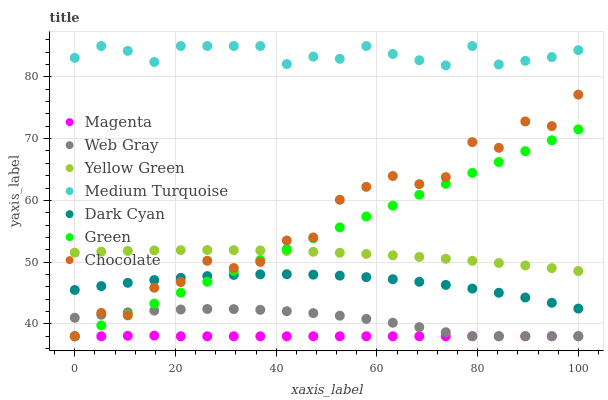Does Magenta have the minimum area under the curve?
Answer yes or no. Yes. Does Medium Turquoise have the maximum area under the curve?
Answer yes or no. Yes. Does Yellow Green have the minimum area under the curve?
Answer yes or no. No. Does Yellow Green have the maximum area under the curve?
Answer yes or no. No. Is Green the smoothest?
Answer yes or no. Yes. Is Chocolate the roughest?
Answer yes or no. Yes. Is Yellow Green the smoothest?
Answer yes or no. No. Is Yellow Green the roughest?
Answer yes or no. No. Does Web Gray have the lowest value?
Answer yes or no. Yes. Does Yellow Green have the lowest value?
Answer yes or no. No. Does Medium Turquoise have the highest value?
Answer yes or no. Yes. Does Yellow Green have the highest value?
Answer yes or no. No. Is Web Gray less than Yellow Green?
Answer yes or no. Yes. Is Medium Turquoise greater than Green?
Answer yes or no. Yes. Does Green intersect Yellow Green?
Answer yes or no. Yes. Is Green less than Yellow Green?
Answer yes or no. No. Is Green greater than Yellow Green?
Answer yes or no. No. Does Web Gray intersect Yellow Green?
Answer yes or no. No. 